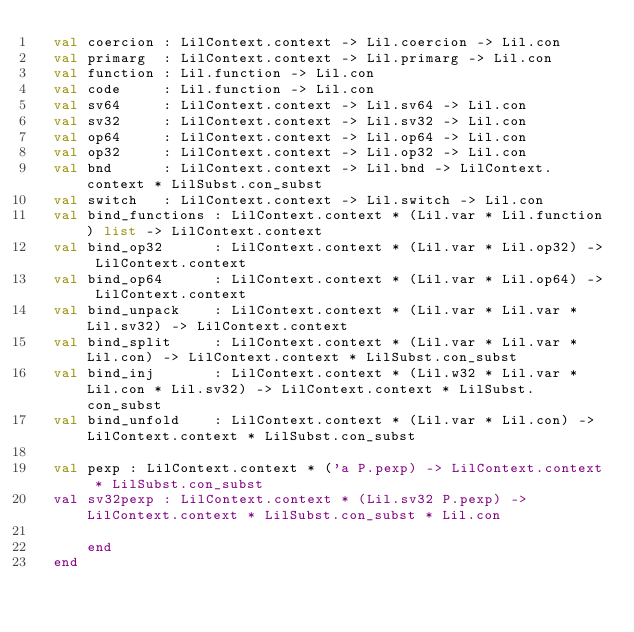<code> <loc_0><loc_0><loc_500><loc_500><_SML_>	val coercion : LilContext.context -> Lil.coercion -> Lil.con
	val primarg  : LilContext.context -> Lil.primarg -> Lil.con
	val function : Lil.function -> Lil.con
	val code     : Lil.function -> Lil.con
	val sv64     : LilContext.context -> Lil.sv64 -> Lil.con 
	val sv32     : LilContext.context -> Lil.sv32 -> Lil.con
	val op64     : LilContext.context -> Lil.op64 -> Lil.con
	val op32     : LilContext.context -> Lil.op32 -> Lil.con
	val bnd      : LilContext.context -> Lil.bnd -> LilContext.context * LilSubst.con_subst
	val switch   : LilContext.context -> Lil.switch -> Lil.con
	val bind_functions : LilContext.context * (Lil.var * Lil.function) list -> LilContext.context
	val bind_op32      : LilContext.context * (Lil.var * Lil.op32) -> LilContext.context
	val bind_op64      : LilContext.context * (Lil.var * Lil.op64) -> LilContext.context
	val bind_unpack    : LilContext.context * (Lil.var * Lil.var * Lil.sv32) -> LilContext.context
	val bind_split     : LilContext.context * (Lil.var * Lil.var * Lil.con) -> LilContext.context * LilSubst.con_subst
	val bind_inj       : LilContext.context * (Lil.w32 * Lil.var * Lil.con * Lil.sv32) -> LilContext.context * LilSubst.con_subst
	val bind_unfold    : LilContext.context * (Lil.var * Lil.con) -> LilContext.context * LilSubst.con_subst

	val pexp : LilContext.context * ('a P.pexp) -> LilContext.context * LilSubst.con_subst
	val sv32pexp : LilContext.context * (Lil.sv32 P.pexp) -> LilContext.context * LilSubst.con_subst * Lil.con
	  
      end
  end      

</code> 